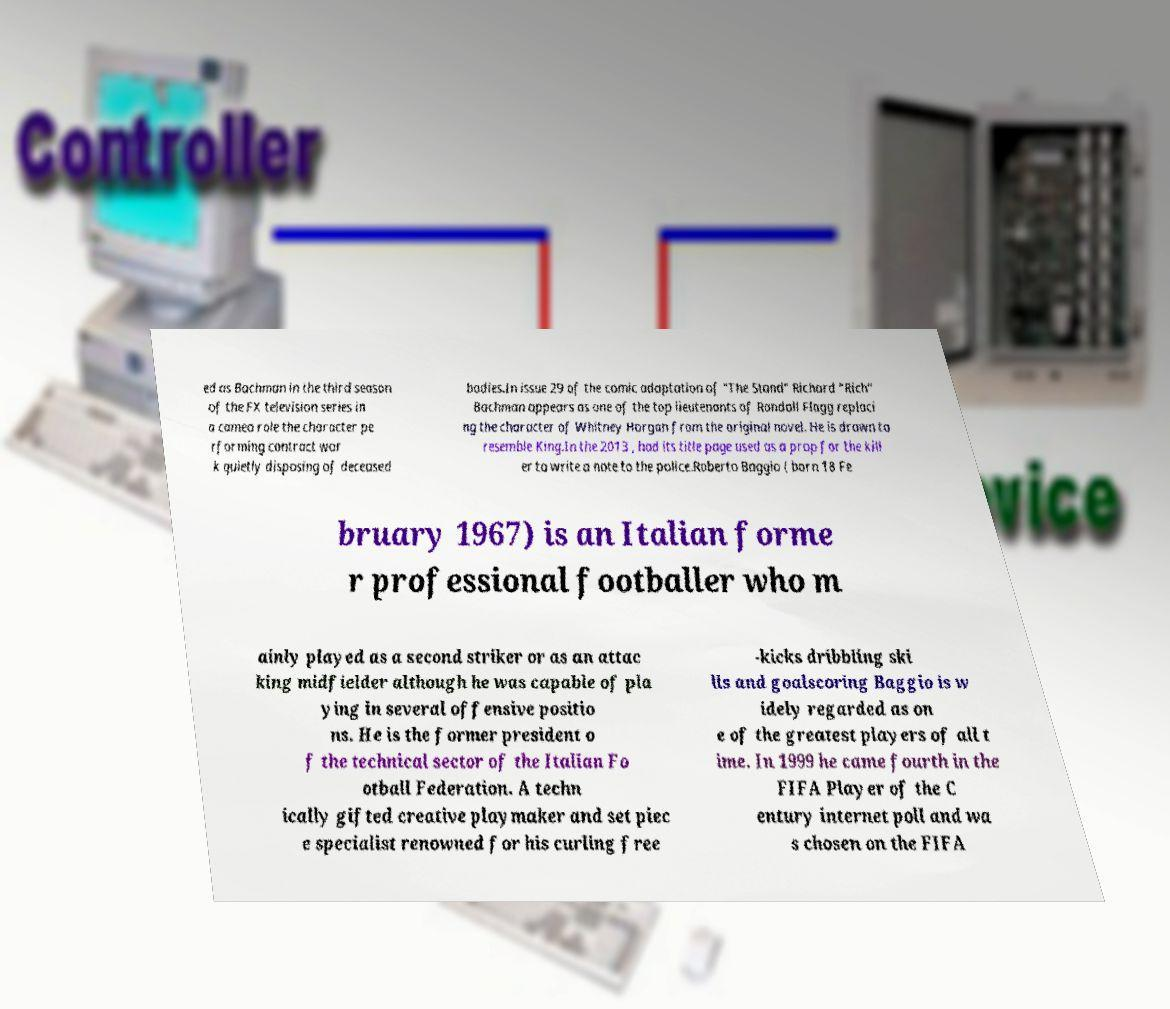Could you extract and type out the text from this image? ed as Bachman in the third season of the FX television series in a cameo role the character pe rforming contract wor k quietly disposing of deceased bodies.In issue 29 of the comic adaptation of "The Stand" Richard “Rich” Bachman appears as one of the top lieutenants of Randall Flagg replaci ng the character of Whitney Horgan from the original novel. He is drawn to resemble King.In the 2013 , had its title page used as a prop for the kill er to write a note to the police.Roberto Baggio ( born 18 Fe bruary 1967) is an Italian forme r professional footballer who m ainly played as a second striker or as an attac king midfielder although he was capable of pla ying in several offensive positio ns. He is the former president o f the technical sector of the Italian Fo otball Federation. A techn ically gifted creative playmaker and set piec e specialist renowned for his curling free -kicks dribbling ski lls and goalscoring Baggio is w idely regarded as on e of the greatest players of all t ime. In 1999 he came fourth in the FIFA Player of the C entury internet poll and wa s chosen on the FIFA 